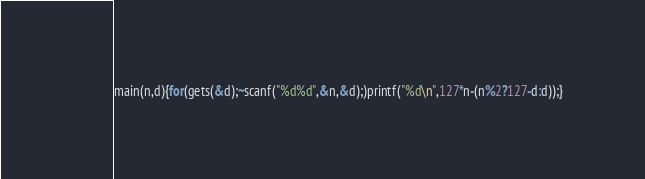Convert code to text. <code><loc_0><loc_0><loc_500><loc_500><_C_>main(n,d){for(gets(&d);~scanf("%d%d",&n,&d);)printf("%d\n",127*n-(n%2?127-d:d));}</code> 